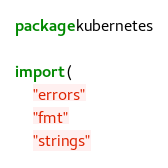Convert code to text. <code><loc_0><loc_0><loc_500><loc_500><_Go_>package kubernetes

import (
	"errors"
	"fmt"
	"strings"
</code> 